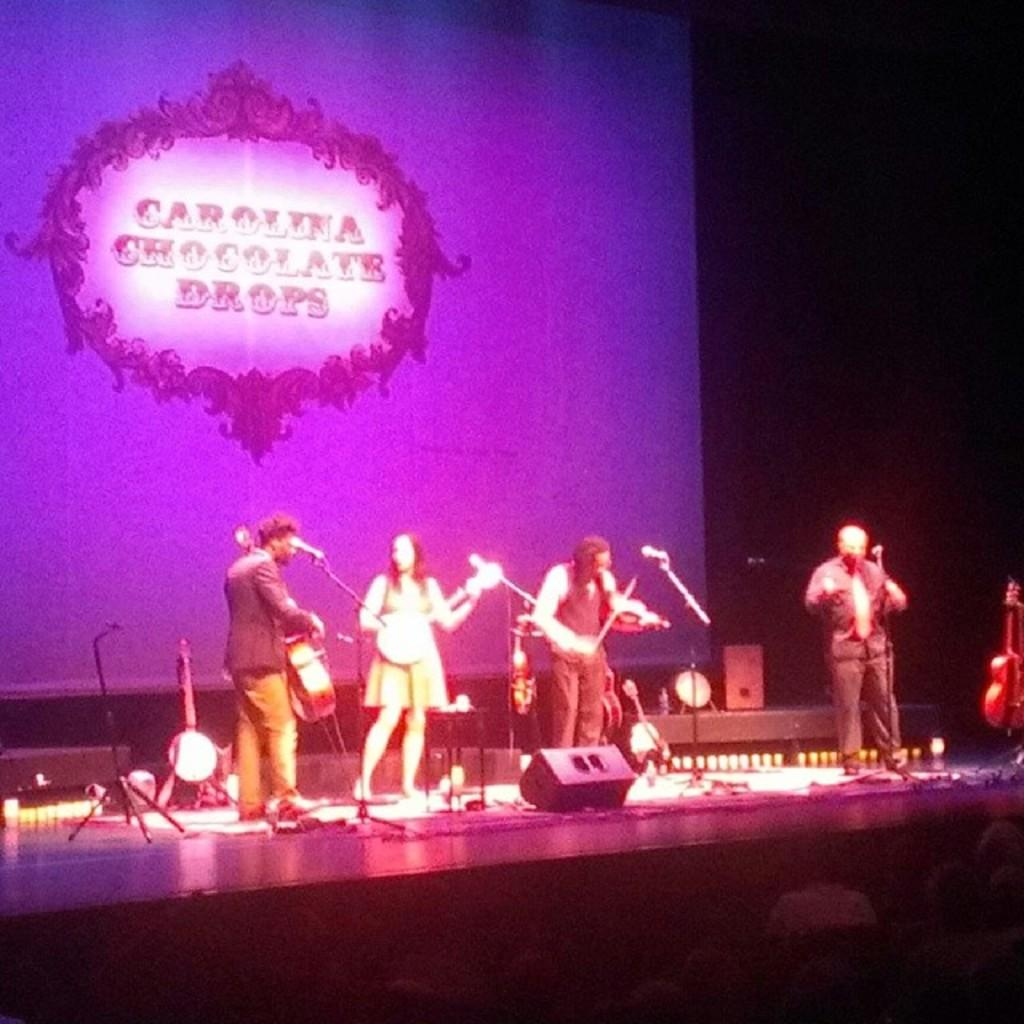How many people are in the image? There are three people in the image. What are the people doing in the image? The people are standing in the image. What objects are the people holding in their hands? The people are holding guitars in their hands. What type of cable can be seen connecting the guitars in the image? There is no cable connecting the guitars in the image; the guitars are simply being held by the people. 